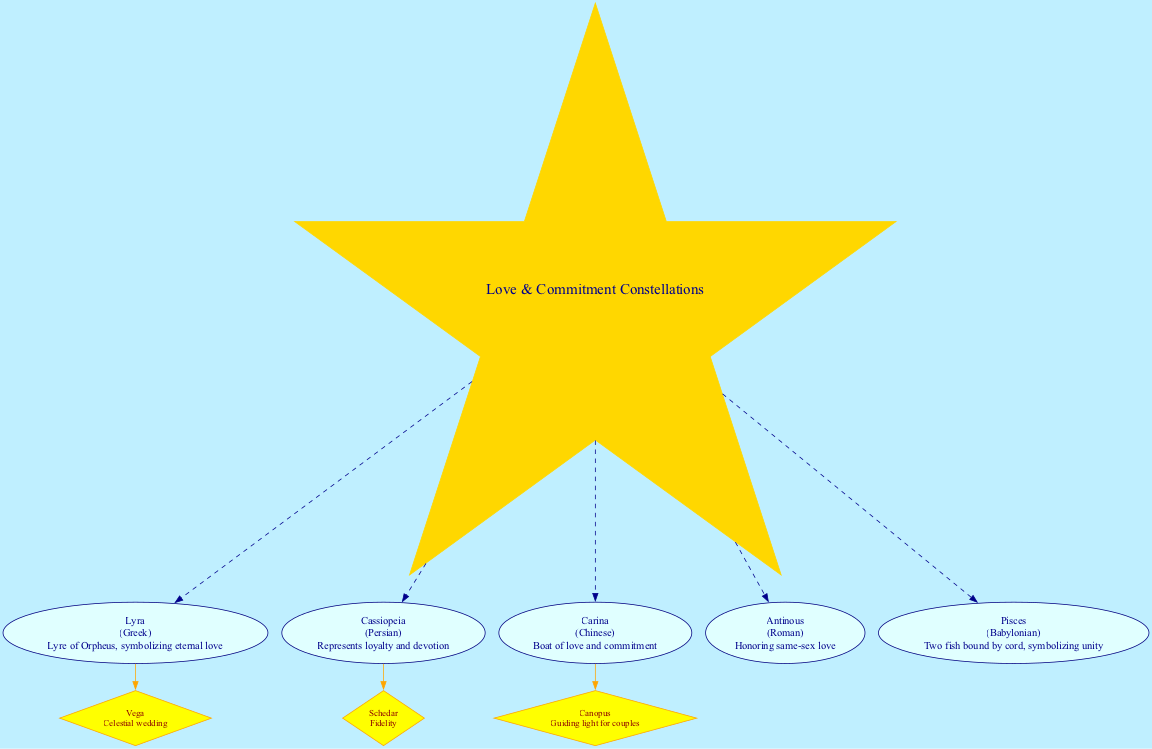What is the central theme of the diagram? The center of the diagram is labeled "Love & Commitment Constellations," which illustrates that the primary focus of this diagram is on celestial symbols that represent love and commitment across different cultures.
Answer: Love & Commitment Constellations How many constellations are associated with love in the diagram? There are five constellations listed in the diagram: Lyra, Cassiopeia, Carina, Antinous, and Pisces. Therefore, the total number of constellations mentioned is five.
Answer: 5 What does the constellation Lyra symbolize? The diagram states that Lyra, associated with the Greek culture, symbolizes "Lyre of Orpheus, symbolizing eternal love." This explicitly describes the meaning attributed to the constellation in the context of love.
Answer: Lyre of Orpheus, symbolizing eternal love Which culture is associated with the constellation Antinous? The diagram specifies that Antinous is associated with the Roman culture. This information outlines the cultural significance of the constellation related to love and commitment.
Answer: Roman Which star is a guiding light for couples? According to the diagram, Canopus, which is part of the constellation Carina, is described as the "Guiding light for couples," indicating its importance in representing love within this cultural context.
Answer: Canopus What does the constellation Pisces represent? The representation for Pisces in the diagram is "Two fish bound by cord, symbolizing unity," showcasing its significance related to love and commitment through unity in relationships.
Answer: Two fish bound by cord, symbolizing unity Which constellation represents loyalty and devotion? The diagram indicates that the constellation Cassiopeia represents "loyalty and devotion," reflecting its cultural importance in the context of love.
Answer: Loyalty and devotion Which two constellations are associated with same-sex love? By examining the diagram, Antinous stands out as a constellation specifically honoring same-sex love; however, no other constellation indicates such representation in this context. Therefore, the identifying constellation is Antinous.
Answer: Antinous What is the meaning of the star Schedar? The diagram provides that Schedar, a notable star in Cassiopeia, represents "Fidelity." This sheds light on the values and qualities of relationships symbolized by the stars.
Answer: Fidelity 